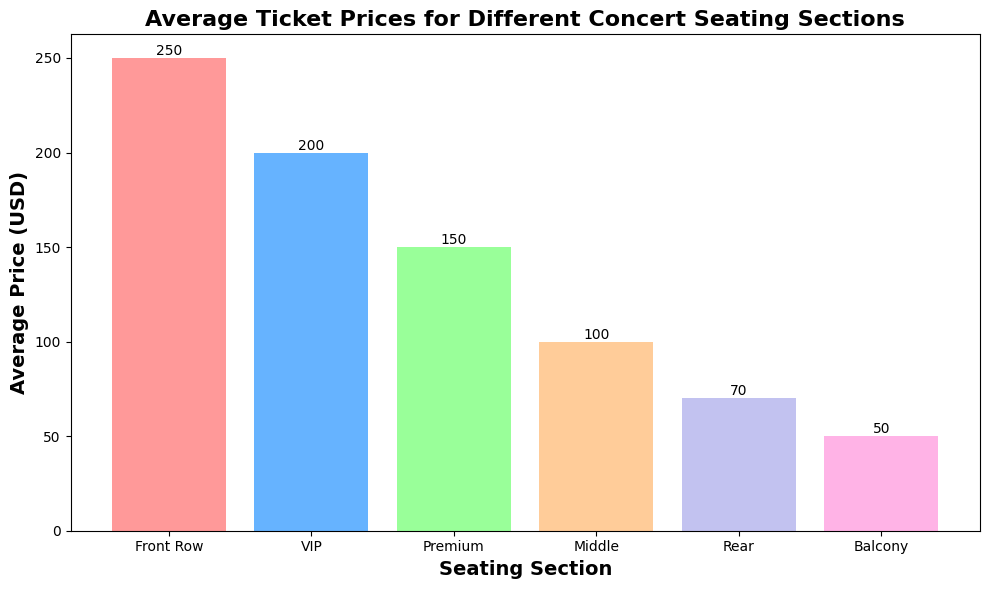what is the average price of the Front Row section? The figure shows the average ticket prices for different seating sections, and the Front Row section is listed with an average price of 250 USD.
Answer: 250 USD Which seating section has the lowest average ticket price? By identifying the bar that represents the lowest value, it can be seen that the Balcony section has the lowest average price, which is 50 USD.
Answer: Balcony How much more expensive is the VIP section than the Rear section? To find the difference in average prices between the VIP section (200 USD) and the Rear section (70 USD), we subtract 70 from 200. So, 200 - 70 = 130 USD.
Answer: 130 USD Which seating sections have an average price greater than 100 USD? Checking the bars exceeding 100 USD, the sections are Front Row (250 USD), VIP (200 USD), and Premium (150 USD).
Answer: Front Row, VIP, Premium What is the total average price for the Middle and Rear sections combined? Adding the average prices of the Middle (100 USD) and Rear (70 USD) sections yields a total of 100 + 70 = 170 USD.
Answer: 170 USD Compare the average price for the Premium and Balcony sections. Which is higher and by how much? The Premium section has an average price of 150 USD, and the Balcony section has 50 USD. Subtracting 50 from 150 shows the Premium section is higher by 150 - 50 = 100 USD.
Answer: Premium, 100 USD What is the average of all the seating section prices? Adding all the average prices together and then dividing by the number of sections gives (250 + 200 + 150 + 100 + 70 + 50) / 6 = 820 / 6 ≈ 136.67 USD.
Answer: 136.67 USD Which section has a price double that of the Balcony section? The Balcony section price is 50 USD. Doubling this gives 2 * 50 = 100 USD, which matches the Middle section price.
Answer: Middle Identify the section with an average price closest to 75 USD. By observing the bars near the 75 USD line, it is clear that the Rear section, with an average price of 70 USD, is the closest.
Answer: Rear What percentage of the Front Row section’s price is the VIP section’s price? The Front Row's price is 250 USD and the VIP's is 200 USD. Calculating the percentage gives (200 / 250) * 100 = 80%.
Answer: 80% 